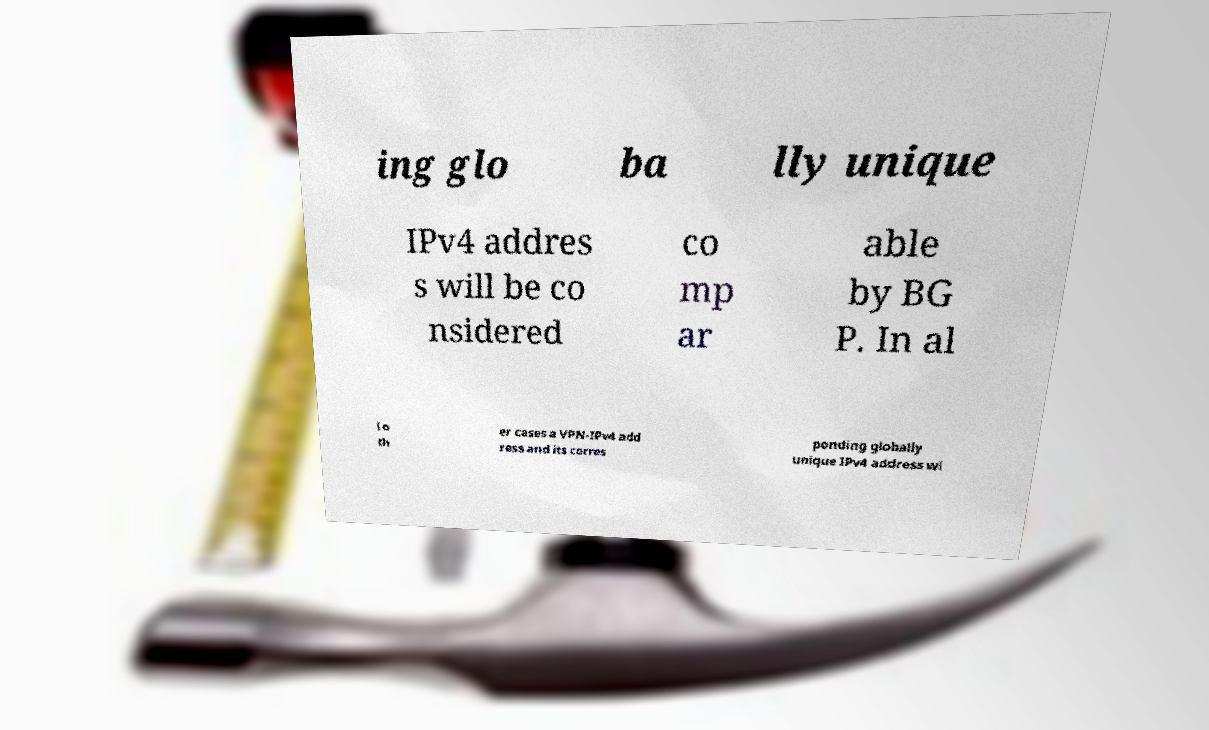Please read and relay the text visible in this image. What does it say? ing glo ba lly unique IPv4 addres s will be co nsidered co mp ar able by BG P. In al l o th er cases a VPN-IPv4 add ress and its corres ponding globally unique IPv4 address wi 